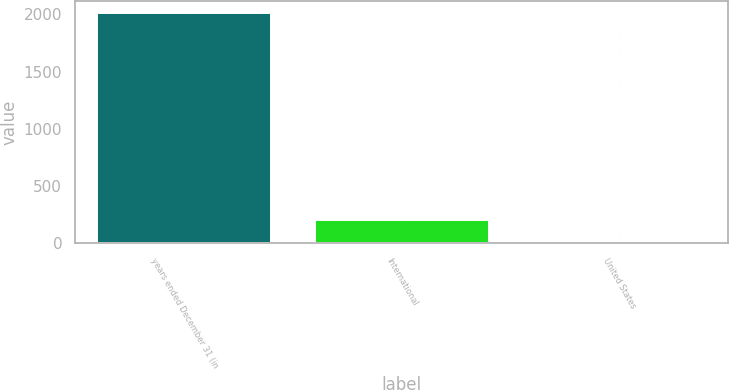<chart> <loc_0><loc_0><loc_500><loc_500><bar_chart><fcel>years ended December 31 (in<fcel>International<fcel>United States<nl><fcel>2013<fcel>202.2<fcel>1<nl></chart> 